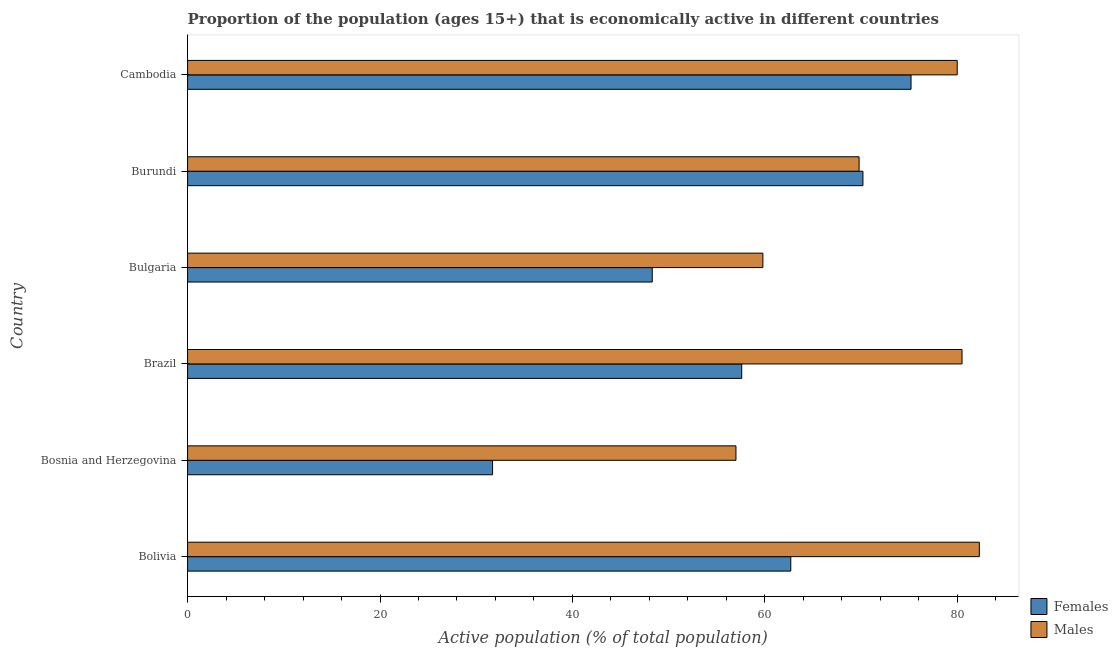How many bars are there on the 2nd tick from the top?
Give a very brief answer. 2. How many bars are there on the 5th tick from the bottom?
Provide a short and direct response. 2. What is the label of the 1st group of bars from the top?
Ensure brevity in your answer.  Cambodia. What is the percentage of economically active male population in Brazil?
Give a very brief answer. 80.5. Across all countries, what is the maximum percentage of economically active female population?
Your answer should be compact. 75.2. Across all countries, what is the minimum percentage of economically active male population?
Keep it short and to the point. 57. In which country was the percentage of economically active male population minimum?
Your answer should be compact. Bosnia and Herzegovina. What is the total percentage of economically active male population in the graph?
Make the answer very short. 429.4. What is the difference between the percentage of economically active male population in Bosnia and Herzegovina and that in Cambodia?
Your response must be concise. -23. What is the difference between the percentage of economically active male population in Brazil and the percentage of economically active female population in Bosnia and Herzegovina?
Provide a succinct answer. 48.8. What is the average percentage of economically active male population per country?
Offer a very short reply. 71.57. What is the difference between the percentage of economically active female population and percentage of economically active male population in Bosnia and Herzegovina?
Your answer should be compact. -25.3. What is the ratio of the percentage of economically active male population in Bolivia to that in Bosnia and Herzegovina?
Offer a very short reply. 1.44. Is the percentage of economically active female population in Bolivia less than that in Bosnia and Herzegovina?
Provide a short and direct response. No. What is the difference between the highest and the second highest percentage of economically active male population?
Offer a very short reply. 1.8. What is the difference between the highest and the lowest percentage of economically active male population?
Your answer should be very brief. 25.3. In how many countries, is the percentage of economically active female population greater than the average percentage of economically active female population taken over all countries?
Your answer should be compact. 3. What does the 1st bar from the top in Bosnia and Herzegovina represents?
Your answer should be very brief. Males. What does the 2nd bar from the bottom in Burundi represents?
Your answer should be compact. Males. How many countries are there in the graph?
Your answer should be very brief. 6. Where does the legend appear in the graph?
Give a very brief answer. Bottom right. How many legend labels are there?
Ensure brevity in your answer.  2. What is the title of the graph?
Offer a terse response. Proportion of the population (ages 15+) that is economically active in different countries. What is the label or title of the X-axis?
Offer a very short reply. Active population (% of total population). What is the label or title of the Y-axis?
Make the answer very short. Country. What is the Active population (% of total population) of Females in Bolivia?
Your answer should be very brief. 62.7. What is the Active population (% of total population) of Males in Bolivia?
Offer a terse response. 82.3. What is the Active population (% of total population) of Females in Bosnia and Herzegovina?
Your answer should be compact. 31.7. What is the Active population (% of total population) of Females in Brazil?
Give a very brief answer. 57.6. What is the Active population (% of total population) in Males in Brazil?
Give a very brief answer. 80.5. What is the Active population (% of total population) in Females in Bulgaria?
Your answer should be compact. 48.3. What is the Active population (% of total population) of Males in Bulgaria?
Provide a succinct answer. 59.8. What is the Active population (% of total population) in Females in Burundi?
Give a very brief answer. 70.2. What is the Active population (% of total population) in Males in Burundi?
Provide a succinct answer. 69.8. What is the Active population (% of total population) in Females in Cambodia?
Make the answer very short. 75.2. What is the Active population (% of total population) in Males in Cambodia?
Keep it short and to the point. 80. Across all countries, what is the maximum Active population (% of total population) of Females?
Give a very brief answer. 75.2. Across all countries, what is the maximum Active population (% of total population) in Males?
Provide a short and direct response. 82.3. Across all countries, what is the minimum Active population (% of total population) of Females?
Keep it short and to the point. 31.7. Across all countries, what is the minimum Active population (% of total population) in Males?
Your answer should be compact. 57. What is the total Active population (% of total population) of Females in the graph?
Offer a terse response. 345.7. What is the total Active population (% of total population) in Males in the graph?
Keep it short and to the point. 429.4. What is the difference between the Active population (% of total population) in Females in Bolivia and that in Bosnia and Herzegovina?
Give a very brief answer. 31. What is the difference between the Active population (% of total population) in Males in Bolivia and that in Bosnia and Herzegovina?
Provide a short and direct response. 25.3. What is the difference between the Active population (% of total population) in Females in Bolivia and that in Brazil?
Your answer should be very brief. 5.1. What is the difference between the Active population (% of total population) in Females in Bolivia and that in Bulgaria?
Keep it short and to the point. 14.4. What is the difference between the Active population (% of total population) of Females in Bolivia and that in Burundi?
Offer a very short reply. -7.5. What is the difference between the Active population (% of total population) of Males in Bolivia and that in Burundi?
Your answer should be very brief. 12.5. What is the difference between the Active population (% of total population) of Females in Bolivia and that in Cambodia?
Offer a terse response. -12.5. What is the difference between the Active population (% of total population) in Males in Bolivia and that in Cambodia?
Offer a terse response. 2.3. What is the difference between the Active population (% of total population) in Females in Bosnia and Herzegovina and that in Brazil?
Make the answer very short. -25.9. What is the difference between the Active population (% of total population) in Males in Bosnia and Herzegovina and that in Brazil?
Provide a succinct answer. -23.5. What is the difference between the Active population (% of total population) in Females in Bosnia and Herzegovina and that in Bulgaria?
Keep it short and to the point. -16.6. What is the difference between the Active population (% of total population) of Females in Bosnia and Herzegovina and that in Burundi?
Make the answer very short. -38.5. What is the difference between the Active population (% of total population) of Males in Bosnia and Herzegovina and that in Burundi?
Ensure brevity in your answer.  -12.8. What is the difference between the Active population (% of total population) of Females in Bosnia and Herzegovina and that in Cambodia?
Keep it short and to the point. -43.5. What is the difference between the Active population (% of total population) in Males in Bosnia and Herzegovina and that in Cambodia?
Provide a succinct answer. -23. What is the difference between the Active population (% of total population) of Males in Brazil and that in Bulgaria?
Ensure brevity in your answer.  20.7. What is the difference between the Active population (% of total population) of Females in Brazil and that in Burundi?
Offer a very short reply. -12.6. What is the difference between the Active population (% of total population) of Males in Brazil and that in Burundi?
Your answer should be very brief. 10.7. What is the difference between the Active population (% of total population) of Females in Brazil and that in Cambodia?
Your answer should be very brief. -17.6. What is the difference between the Active population (% of total population) of Males in Brazil and that in Cambodia?
Give a very brief answer. 0.5. What is the difference between the Active population (% of total population) in Females in Bulgaria and that in Burundi?
Give a very brief answer. -21.9. What is the difference between the Active population (% of total population) in Males in Bulgaria and that in Burundi?
Your answer should be compact. -10. What is the difference between the Active population (% of total population) of Females in Bulgaria and that in Cambodia?
Make the answer very short. -26.9. What is the difference between the Active population (% of total population) of Males in Bulgaria and that in Cambodia?
Your answer should be very brief. -20.2. What is the difference between the Active population (% of total population) in Females in Burundi and that in Cambodia?
Offer a terse response. -5. What is the difference between the Active population (% of total population) of Females in Bolivia and the Active population (% of total population) of Males in Bosnia and Herzegovina?
Offer a terse response. 5.7. What is the difference between the Active population (% of total population) of Females in Bolivia and the Active population (% of total population) of Males in Brazil?
Provide a short and direct response. -17.8. What is the difference between the Active population (% of total population) in Females in Bolivia and the Active population (% of total population) in Males in Cambodia?
Offer a very short reply. -17.3. What is the difference between the Active population (% of total population) in Females in Bosnia and Herzegovina and the Active population (% of total population) in Males in Brazil?
Offer a terse response. -48.8. What is the difference between the Active population (% of total population) in Females in Bosnia and Herzegovina and the Active population (% of total population) in Males in Bulgaria?
Your answer should be compact. -28.1. What is the difference between the Active population (% of total population) in Females in Bosnia and Herzegovina and the Active population (% of total population) in Males in Burundi?
Ensure brevity in your answer.  -38.1. What is the difference between the Active population (% of total population) in Females in Bosnia and Herzegovina and the Active population (% of total population) in Males in Cambodia?
Your answer should be very brief. -48.3. What is the difference between the Active population (% of total population) of Females in Brazil and the Active population (% of total population) of Males in Bulgaria?
Make the answer very short. -2.2. What is the difference between the Active population (% of total population) in Females in Brazil and the Active population (% of total population) in Males in Burundi?
Your answer should be very brief. -12.2. What is the difference between the Active population (% of total population) of Females in Brazil and the Active population (% of total population) of Males in Cambodia?
Make the answer very short. -22.4. What is the difference between the Active population (% of total population) of Females in Bulgaria and the Active population (% of total population) of Males in Burundi?
Make the answer very short. -21.5. What is the difference between the Active population (% of total population) in Females in Bulgaria and the Active population (% of total population) in Males in Cambodia?
Offer a very short reply. -31.7. What is the average Active population (% of total population) of Females per country?
Provide a short and direct response. 57.62. What is the average Active population (% of total population) of Males per country?
Ensure brevity in your answer.  71.57. What is the difference between the Active population (% of total population) in Females and Active population (% of total population) in Males in Bolivia?
Your answer should be very brief. -19.6. What is the difference between the Active population (% of total population) in Females and Active population (% of total population) in Males in Bosnia and Herzegovina?
Make the answer very short. -25.3. What is the difference between the Active population (% of total population) in Females and Active population (% of total population) in Males in Brazil?
Keep it short and to the point. -22.9. What is the difference between the Active population (% of total population) in Females and Active population (% of total population) in Males in Burundi?
Ensure brevity in your answer.  0.4. What is the ratio of the Active population (% of total population) of Females in Bolivia to that in Bosnia and Herzegovina?
Give a very brief answer. 1.98. What is the ratio of the Active population (% of total population) of Males in Bolivia to that in Bosnia and Herzegovina?
Ensure brevity in your answer.  1.44. What is the ratio of the Active population (% of total population) of Females in Bolivia to that in Brazil?
Ensure brevity in your answer.  1.09. What is the ratio of the Active population (% of total population) in Males in Bolivia to that in Brazil?
Offer a terse response. 1.02. What is the ratio of the Active population (% of total population) of Females in Bolivia to that in Bulgaria?
Make the answer very short. 1.3. What is the ratio of the Active population (% of total population) in Males in Bolivia to that in Bulgaria?
Provide a short and direct response. 1.38. What is the ratio of the Active population (% of total population) of Females in Bolivia to that in Burundi?
Provide a short and direct response. 0.89. What is the ratio of the Active population (% of total population) of Males in Bolivia to that in Burundi?
Offer a very short reply. 1.18. What is the ratio of the Active population (% of total population) of Females in Bolivia to that in Cambodia?
Make the answer very short. 0.83. What is the ratio of the Active population (% of total population) in Males in Bolivia to that in Cambodia?
Keep it short and to the point. 1.03. What is the ratio of the Active population (% of total population) in Females in Bosnia and Herzegovina to that in Brazil?
Keep it short and to the point. 0.55. What is the ratio of the Active population (% of total population) of Males in Bosnia and Herzegovina to that in Brazil?
Offer a terse response. 0.71. What is the ratio of the Active population (% of total population) in Females in Bosnia and Herzegovina to that in Bulgaria?
Provide a succinct answer. 0.66. What is the ratio of the Active population (% of total population) of Males in Bosnia and Herzegovina to that in Bulgaria?
Your response must be concise. 0.95. What is the ratio of the Active population (% of total population) in Females in Bosnia and Herzegovina to that in Burundi?
Your response must be concise. 0.45. What is the ratio of the Active population (% of total population) of Males in Bosnia and Herzegovina to that in Burundi?
Offer a very short reply. 0.82. What is the ratio of the Active population (% of total population) of Females in Bosnia and Herzegovina to that in Cambodia?
Make the answer very short. 0.42. What is the ratio of the Active population (% of total population) in Males in Bosnia and Herzegovina to that in Cambodia?
Your answer should be compact. 0.71. What is the ratio of the Active population (% of total population) in Females in Brazil to that in Bulgaria?
Provide a succinct answer. 1.19. What is the ratio of the Active population (% of total population) of Males in Brazil to that in Bulgaria?
Your answer should be compact. 1.35. What is the ratio of the Active population (% of total population) in Females in Brazil to that in Burundi?
Make the answer very short. 0.82. What is the ratio of the Active population (% of total population) of Males in Brazil to that in Burundi?
Offer a very short reply. 1.15. What is the ratio of the Active population (% of total population) of Females in Brazil to that in Cambodia?
Make the answer very short. 0.77. What is the ratio of the Active population (% of total population) of Females in Bulgaria to that in Burundi?
Ensure brevity in your answer.  0.69. What is the ratio of the Active population (% of total population) in Males in Bulgaria to that in Burundi?
Provide a succinct answer. 0.86. What is the ratio of the Active population (% of total population) of Females in Bulgaria to that in Cambodia?
Your response must be concise. 0.64. What is the ratio of the Active population (% of total population) in Males in Bulgaria to that in Cambodia?
Keep it short and to the point. 0.75. What is the ratio of the Active population (% of total population) in Females in Burundi to that in Cambodia?
Provide a succinct answer. 0.93. What is the ratio of the Active population (% of total population) in Males in Burundi to that in Cambodia?
Offer a very short reply. 0.87. What is the difference between the highest and the lowest Active population (% of total population) of Females?
Your answer should be very brief. 43.5. What is the difference between the highest and the lowest Active population (% of total population) in Males?
Make the answer very short. 25.3. 